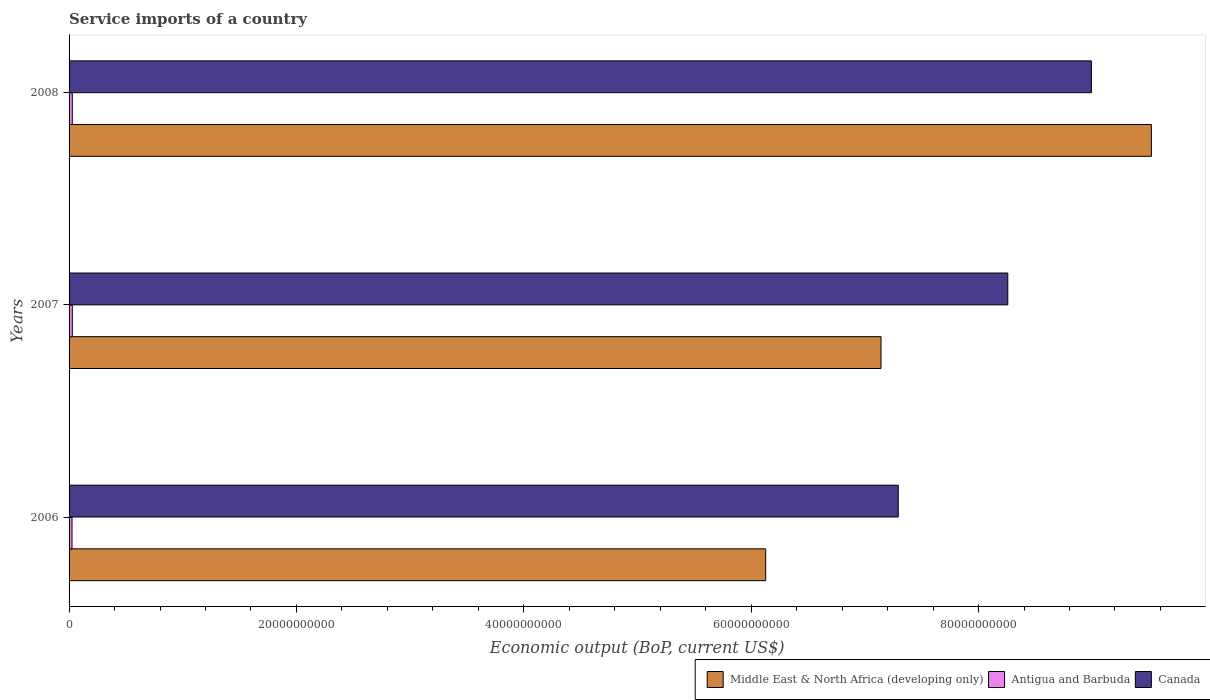How many different coloured bars are there?
Your answer should be very brief. 3. Are the number of bars on each tick of the Y-axis equal?
Offer a very short reply. Yes. How many bars are there on the 2nd tick from the top?
Keep it short and to the point. 3. What is the service imports in Antigua and Barbuda in 2008?
Offer a very short reply. 2.82e+08. Across all years, what is the maximum service imports in Canada?
Offer a very short reply. 8.99e+1. Across all years, what is the minimum service imports in Canada?
Provide a short and direct response. 7.29e+1. In which year was the service imports in Antigua and Barbuda maximum?
Offer a terse response. 2007. In which year was the service imports in Middle East & North Africa (developing only) minimum?
Make the answer very short. 2006. What is the total service imports in Canada in the graph?
Provide a short and direct response. 2.45e+11. What is the difference between the service imports in Middle East & North Africa (developing only) in 2006 and that in 2008?
Your answer should be very brief. -3.39e+1. What is the difference between the service imports in Middle East & North Africa (developing only) in 2006 and the service imports in Canada in 2007?
Ensure brevity in your answer.  -2.13e+1. What is the average service imports in Canada per year?
Your answer should be very brief. 8.18e+1. In the year 2006, what is the difference between the service imports in Antigua and Barbuda and service imports in Canada?
Keep it short and to the point. -7.27e+1. What is the ratio of the service imports in Canada in 2006 to that in 2007?
Your answer should be compact. 0.88. What is the difference between the highest and the second highest service imports in Middle East & North Africa (developing only)?
Provide a succinct answer. 2.38e+1. What is the difference between the highest and the lowest service imports in Middle East & North Africa (developing only)?
Your answer should be compact. 3.39e+1. In how many years, is the service imports in Canada greater than the average service imports in Canada taken over all years?
Your answer should be compact. 2. What does the 2nd bar from the top in 2007 represents?
Ensure brevity in your answer.  Antigua and Barbuda. What does the 1st bar from the bottom in 2006 represents?
Ensure brevity in your answer.  Middle East & North Africa (developing only). Is it the case that in every year, the sum of the service imports in Canada and service imports in Antigua and Barbuda is greater than the service imports in Middle East & North Africa (developing only)?
Provide a short and direct response. No. Are all the bars in the graph horizontal?
Offer a terse response. Yes. What is the difference between two consecutive major ticks on the X-axis?
Offer a terse response. 2.00e+1. Are the values on the major ticks of X-axis written in scientific E-notation?
Your answer should be very brief. No. Does the graph contain any zero values?
Offer a very short reply. No. Where does the legend appear in the graph?
Provide a succinct answer. Bottom right. How many legend labels are there?
Provide a succinct answer. 3. How are the legend labels stacked?
Your response must be concise. Horizontal. What is the title of the graph?
Your answer should be very brief. Service imports of a country. Does "Turkmenistan" appear as one of the legend labels in the graph?
Provide a succinct answer. No. What is the label or title of the X-axis?
Your answer should be compact. Economic output (BoP, current US$). What is the label or title of the Y-axis?
Give a very brief answer. Years. What is the Economic output (BoP, current US$) of Middle East & North Africa (developing only) in 2006?
Your response must be concise. 6.13e+1. What is the Economic output (BoP, current US$) in Antigua and Barbuda in 2006?
Your answer should be very brief. 2.59e+08. What is the Economic output (BoP, current US$) in Canada in 2006?
Provide a short and direct response. 7.29e+1. What is the Economic output (BoP, current US$) of Middle East & North Africa (developing only) in 2007?
Keep it short and to the point. 7.14e+1. What is the Economic output (BoP, current US$) of Antigua and Barbuda in 2007?
Give a very brief answer. 2.83e+08. What is the Economic output (BoP, current US$) in Canada in 2007?
Provide a short and direct response. 8.26e+1. What is the Economic output (BoP, current US$) of Middle East & North Africa (developing only) in 2008?
Provide a succinct answer. 9.52e+1. What is the Economic output (BoP, current US$) in Antigua and Barbuda in 2008?
Your answer should be compact. 2.82e+08. What is the Economic output (BoP, current US$) of Canada in 2008?
Your answer should be very brief. 8.99e+1. Across all years, what is the maximum Economic output (BoP, current US$) in Middle East & North Africa (developing only)?
Provide a short and direct response. 9.52e+1. Across all years, what is the maximum Economic output (BoP, current US$) in Antigua and Barbuda?
Provide a short and direct response. 2.83e+08. Across all years, what is the maximum Economic output (BoP, current US$) in Canada?
Provide a short and direct response. 8.99e+1. Across all years, what is the minimum Economic output (BoP, current US$) in Middle East & North Africa (developing only)?
Provide a short and direct response. 6.13e+1. Across all years, what is the minimum Economic output (BoP, current US$) in Antigua and Barbuda?
Ensure brevity in your answer.  2.59e+08. Across all years, what is the minimum Economic output (BoP, current US$) of Canada?
Your answer should be compact. 7.29e+1. What is the total Economic output (BoP, current US$) of Middle East & North Africa (developing only) in the graph?
Keep it short and to the point. 2.28e+11. What is the total Economic output (BoP, current US$) of Antigua and Barbuda in the graph?
Give a very brief answer. 8.24e+08. What is the total Economic output (BoP, current US$) of Canada in the graph?
Offer a very short reply. 2.45e+11. What is the difference between the Economic output (BoP, current US$) of Middle East & North Africa (developing only) in 2006 and that in 2007?
Keep it short and to the point. -1.01e+1. What is the difference between the Economic output (BoP, current US$) in Antigua and Barbuda in 2006 and that in 2007?
Offer a terse response. -2.48e+07. What is the difference between the Economic output (BoP, current US$) of Canada in 2006 and that in 2007?
Give a very brief answer. -9.63e+09. What is the difference between the Economic output (BoP, current US$) in Middle East & North Africa (developing only) in 2006 and that in 2008?
Make the answer very short. -3.39e+1. What is the difference between the Economic output (BoP, current US$) of Antigua and Barbuda in 2006 and that in 2008?
Offer a very short reply. -2.36e+07. What is the difference between the Economic output (BoP, current US$) of Canada in 2006 and that in 2008?
Give a very brief answer. -1.70e+1. What is the difference between the Economic output (BoP, current US$) in Middle East & North Africa (developing only) in 2007 and that in 2008?
Give a very brief answer. -2.38e+1. What is the difference between the Economic output (BoP, current US$) in Antigua and Barbuda in 2007 and that in 2008?
Provide a short and direct response. 1.14e+06. What is the difference between the Economic output (BoP, current US$) of Canada in 2007 and that in 2008?
Your answer should be compact. -7.35e+09. What is the difference between the Economic output (BoP, current US$) in Middle East & North Africa (developing only) in 2006 and the Economic output (BoP, current US$) in Antigua and Barbuda in 2007?
Offer a terse response. 6.10e+1. What is the difference between the Economic output (BoP, current US$) in Middle East & North Africa (developing only) in 2006 and the Economic output (BoP, current US$) in Canada in 2007?
Offer a terse response. -2.13e+1. What is the difference between the Economic output (BoP, current US$) in Antigua and Barbuda in 2006 and the Economic output (BoP, current US$) in Canada in 2007?
Your answer should be compact. -8.23e+1. What is the difference between the Economic output (BoP, current US$) of Middle East & North Africa (developing only) in 2006 and the Economic output (BoP, current US$) of Antigua and Barbuda in 2008?
Your response must be concise. 6.10e+1. What is the difference between the Economic output (BoP, current US$) of Middle East & North Africa (developing only) in 2006 and the Economic output (BoP, current US$) of Canada in 2008?
Provide a short and direct response. -2.87e+1. What is the difference between the Economic output (BoP, current US$) in Antigua and Barbuda in 2006 and the Economic output (BoP, current US$) in Canada in 2008?
Ensure brevity in your answer.  -8.97e+1. What is the difference between the Economic output (BoP, current US$) in Middle East & North Africa (developing only) in 2007 and the Economic output (BoP, current US$) in Antigua and Barbuda in 2008?
Provide a succinct answer. 7.11e+1. What is the difference between the Economic output (BoP, current US$) of Middle East & North Africa (developing only) in 2007 and the Economic output (BoP, current US$) of Canada in 2008?
Provide a succinct answer. -1.85e+1. What is the difference between the Economic output (BoP, current US$) of Antigua and Barbuda in 2007 and the Economic output (BoP, current US$) of Canada in 2008?
Your answer should be compact. -8.96e+1. What is the average Economic output (BoP, current US$) in Middle East & North Africa (developing only) per year?
Offer a terse response. 7.60e+1. What is the average Economic output (BoP, current US$) in Antigua and Barbuda per year?
Your answer should be compact. 2.75e+08. What is the average Economic output (BoP, current US$) in Canada per year?
Your response must be concise. 8.18e+1. In the year 2006, what is the difference between the Economic output (BoP, current US$) in Middle East & North Africa (developing only) and Economic output (BoP, current US$) in Antigua and Barbuda?
Keep it short and to the point. 6.10e+1. In the year 2006, what is the difference between the Economic output (BoP, current US$) in Middle East & North Africa (developing only) and Economic output (BoP, current US$) in Canada?
Offer a terse response. -1.17e+1. In the year 2006, what is the difference between the Economic output (BoP, current US$) of Antigua and Barbuda and Economic output (BoP, current US$) of Canada?
Offer a very short reply. -7.27e+1. In the year 2007, what is the difference between the Economic output (BoP, current US$) of Middle East & North Africa (developing only) and Economic output (BoP, current US$) of Antigua and Barbuda?
Provide a succinct answer. 7.11e+1. In the year 2007, what is the difference between the Economic output (BoP, current US$) of Middle East & North Africa (developing only) and Economic output (BoP, current US$) of Canada?
Offer a very short reply. -1.12e+1. In the year 2007, what is the difference between the Economic output (BoP, current US$) in Antigua and Barbuda and Economic output (BoP, current US$) in Canada?
Offer a terse response. -8.23e+1. In the year 2008, what is the difference between the Economic output (BoP, current US$) of Middle East & North Africa (developing only) and Economic output (BoP, current US$) of Antigua and Barbuda?
Make the answer very short. 9.49e+1. In the year 2008, what is the difference between the Economic output (BoP, current US$) of Middle East & North Africa (developing only) and Economic output (BoP, current US$) of Canada?
Offer a terse response. 5.28e+09. In the year 2008, what is the difference between the Economic output (BoP, current US$) in Antigua and Barbuda and Economic output (BoP, current US$) in Canada?
Offer a terse response. -8.96e+1. What is the ratio of the Economic output (BoP, current US$) of Middle East & North Africa (developing only) in 2006 to that in 2007?
Your answer should be compact. 0.86. What is the ratio of the Economic output (BoP, current US$) in Antigua and Barbuda in 2006 to that in 2007?
Keep it short and to the point. 0.91. What is the ratio of the Economic output (BoP, current US$) of Canada in 2006 to that in 2007?
Ensure brevity in your answer.  0.88. What is the ratio of the Economic output (BoP, current US$) in Middle East & North Africa (developing only) in 2006 to that in 2008?
Provide a short and direct response. 0.64. What is the ratio of the Economic output (BoP, current US$) of Antigua and Barbuda in 2006 to that in 2008?
Your answer should be compact. 0.92. What is the ratio of the Economic output (BoP, current US$) of Canada in 2006 to that in 2008?
Offer a very short reply. 0.81. What is the ratio of the Economic output (BoP, current US$) of Middle East & North Africa (developing only) in 2007 to that in 2008?
Make the answer very short. 0.75. What is the ratio of the Economic output (BoP, current US$) of Antigua and Barbuda in 2007 to that in 2008?
Keep it short and to the point. 1. What is the ratio of the Economic output (BoP, current US$) in Canada in 2007 to that in 2008?
Provide a short and direct response. 0.92. What is the difference between the highest and the second highest Economic output (BoP, current US$) of Middle East & North Africa (developing only)?
Offer a terse response. 2.38e+1. What is the difference between the highest and the second highest Economic output (BoP, current US$) of Antigua and Barbuda?
Offer a terse response. 1.14e+06. What is the difference between the highest and the second highest Economic output (BoP, current US$) in Canada?
Make the answer very short. 7.35e+09. What is the difference between the highest and the lowest Economic output (BoP, current US$) in Middle East & North Africa (developing only)?
Give a very brief answer. 3.39e+1. What is the difference between the highest and the lowest Economic output (BoP, current US$) of Antigua and Barbuda?
Your response must be concise. 2.48e+07. What is the difference between the highest and the lowest Economic output (BoP, current US$) in Canada?
Give a very brief answer. 1.70e+1. 